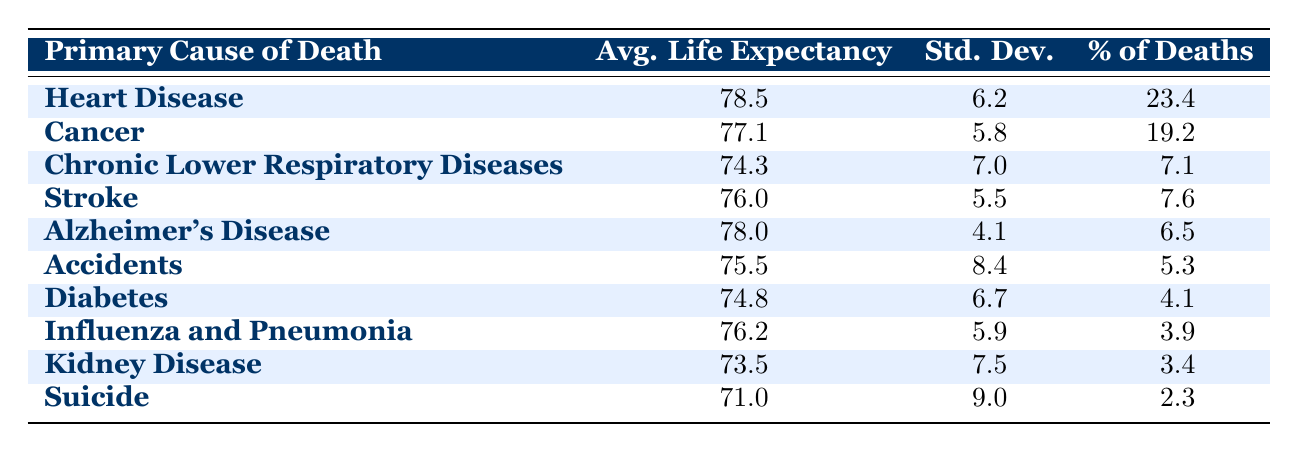What is the average life expectancy for those who die from heart disease? The table shows that the average life expectancy for individuals whose primary cause of death is heart disease is listed under the 'Avg. Life Expectancy' column for heart disease, which is 78.5.
Answer: 78.5 What percentage of deaths in Buncombe County is attributed to cancer? From the table, the 'Percentage of Deaths' for cancer is directly available, showing 19.2 as the value.
Answer: 19.2 Is the average life expectancy for individuals who die from diabetes higher than that for those who die from accidents? According to the table, the average life expectancy for diabetes is 74.8, while for accidents it is 75.5. Since 74.8 is not higher than 75.5, the answer is no.
Answer: No What is the life expectancy difference between those who die from Alzheimer's Disease and those who die from suicide? The average life expectancy for Alzheimer's Disease is 78.0 and for suicide it's 71.0. To find the difference, subtract the latter from the former: 78.0 - 71.0 = 7.0.
Answer: 7.0 Which causes of death have an average life expectancy below 75 years? By checking the 'Avg. Life Expectancy' column, we notice that Chronic Lower Respiratory Diseases (74.3), Diabetes (74.8), Kidney Disease (73.5), and Suicide (71.0) all fall below 75 years.
Answer: Chronic Lower Respiratory Diseases, Diabetes, Kidney Disease, Suicide What is the average life expectancy for the top three causes of death combined? The top three causes by percentage of deaths are heart disease (78.5), cancer (77.1), and stroke (76.0). First, sum these values: 78.5 + 77.1 + 76.0 = 231.6. Then, divide by 3: 231.6 / 3 = 77.2.
Answer: 77.2 Is it true that the standard deviation for deaths caused by stroke is less than that for heart disease? The standard deviation for stroke is 5.5, and for heart disease, it is 6.2. Since 5.5 is indeed less than 6.2, the answer is yes.
Answer: Yes What is the average life expectancy for those who die from chronic lower respiratory diseases compared to those who die from influenza and pneumonia? The average life expectancy for chronic lower respiratory diseases is 74.3, and for influenza and pneumonia, it is 76.2. Since 74.3 is less than 76.2, the statement can be confirmed.
Answer: Less than What is the standard deviation of life expectancy for those who died from accidents? The table indicates that the standard deviation for accidents is 8.4, which reflects the variability in life expectancy for that cause.
Answer: 8.4 